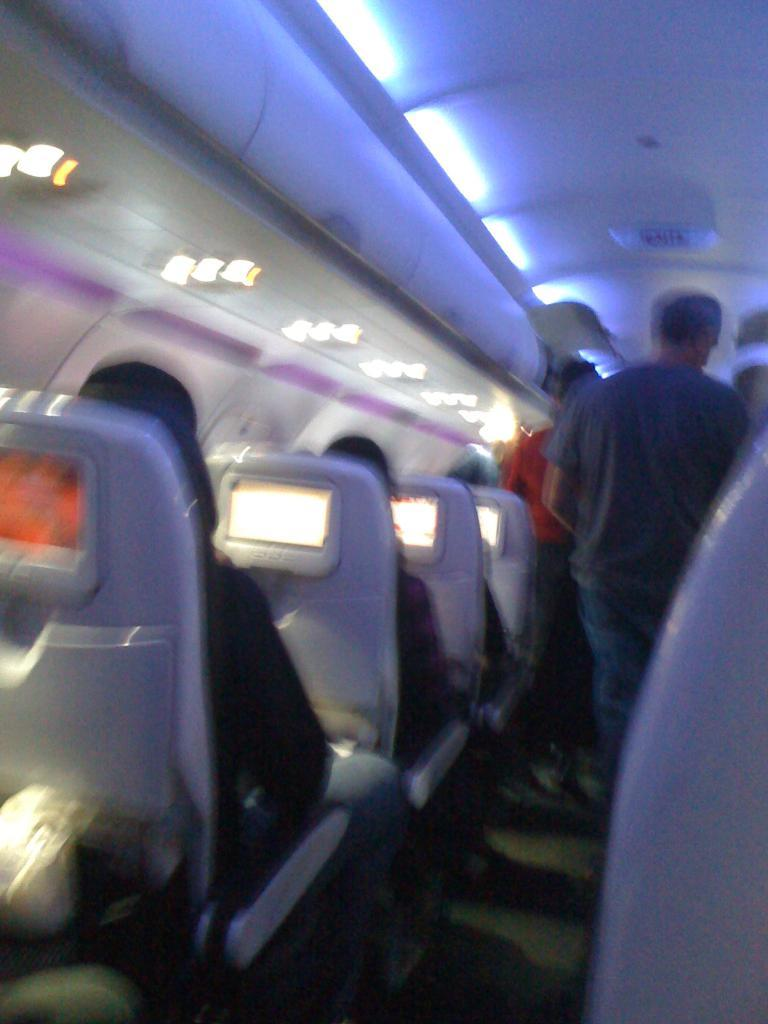What is the quality of the image? The image is blurry. Where do you think the image was taken? The image appears to be captured inside a plane. What are the people in the image doing? There are people sitting on chairs and two people standing in the middle of the image. What type of religion is being practiced by the people in the image? There is no indication of any religious practice in the image; it simply shows people sitting and standing inside a plane. How much milk is being consumed by the people in the image? There is no milk visible in the image, and no information about milk consumption is provided. 